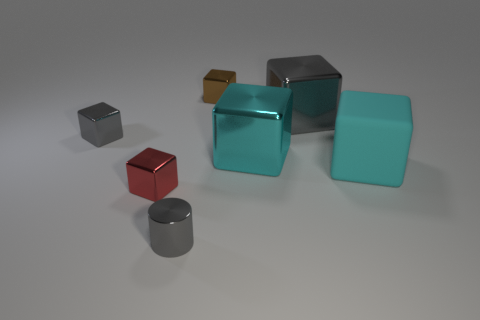Subtract all red blocks. How many blocks are left? 5 Subtract 2 cubes. How many cubes are left? 4 Subtract all brown cubes. How many cubes are left? 5 Subtract all green cubes. Subtract all cyan balls. How many cubes are left? 6 Add 3 tiny blue metal blocks. How many objects exist? 10 Subtract all cylinders. How many objects are left? 6 Add 5 large objects. How many large objects are left? 8 Add 3 tiny red cubes. How many tiny red cubes exist? 4 Subtract 1 brown cubes. How many objects are left? 6 Subtract all small blue cubes. Subtract all tiny red cubes. How many objects are left? 6 